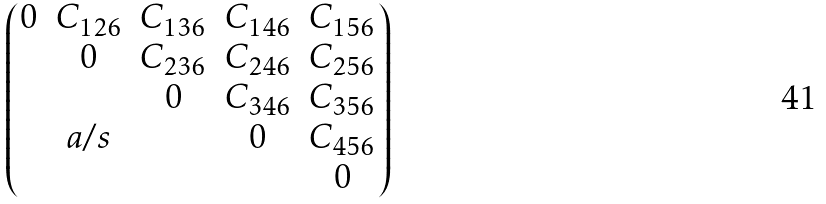<formula> <loc_0><loc_0><loc_500><loc_500>\begin{pmatrix} 0 & C _ { 1 2 6 } & C _ { 1 3 6 } & C _ { 1 4 6 } & C _ { 1 5 6 } \\ & 0 & C _ { 2 3 6 } & C _ { 2 4 6 } & C _ { 2 5 6 } \\ & & 0 & C _ { 3 4 6 } & C _ { 3 5 6 } \\ & a / s & & 0 & C _ { 4 5 6 } \\ & & & & 0 \end{pmatrix}</formula> 